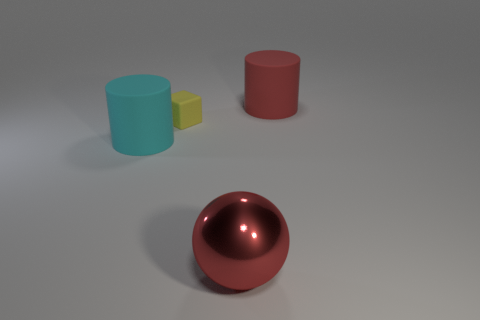Are there any other things that have the same size as the yellow cube?
Your answer should be very brief. No. Is there anything else that has the same material as the red ball?
Provide a short and direct response. No. There is a big object that is in front of the large rubber cylinder that is left of the red object that is on the right side of the metal thing; what is its color?
Offer a terse response. Red. What is the material of the other large thing that is the same shape as the red rubber thing?
Your answer should be very brief. Rubber. What is the color of the small thing?
Give a very brief answer. Yellow. Is the metal thing the same color as the rubber block?
Give a very brief answer. No. How many metal objects are either red spheres or red things?
Your answer should be very brief. 1. There is a red thing that is in front of the matte cylinder right of the tiny yellow matte thing; is there a big cyan rubber object to the right of it?
Give a very brief answer. No. There is a red thing that is the same material as the yellow cube; what is its size?
Your answer should be very brief. Large. There is a small block; are there any yellow matte things behind it?
Your response must be concise. No. 